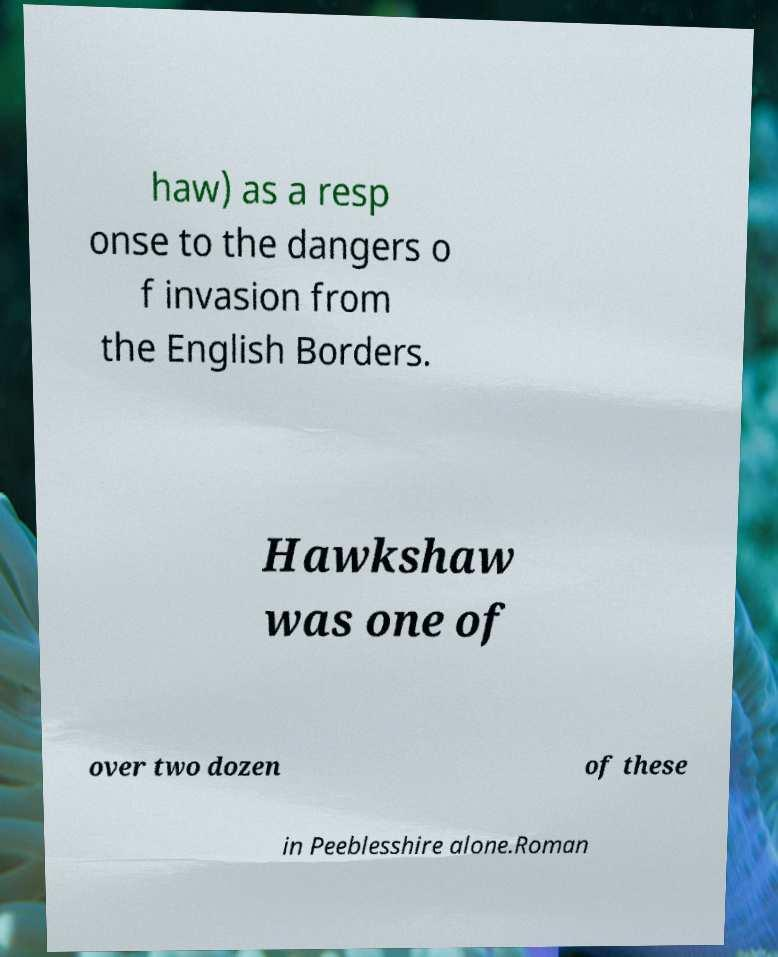Please identify and transcribe the text found in this image. haw) as a resp onse to the dangers o f invasion from the English Borders. Hawkshaw was one of over two dozen of these in Peeblesshire alone.Roman 